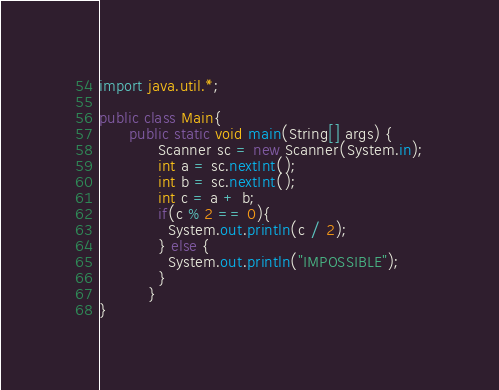<code> <loc_0><loc_0><loc_500><loc_500><_Java_>import java.util.*;

public class Main{
      public static void main(String[] args) {
            Scanner sc = new Scanner(System.in);
            int a = sc.nextInt();
            int b = sc.nextInt();
            int c = a + b;
            if(c % 2 == 0){
              System.out.println(c / 2);
            } else {
              System.out.println("IMPOSSIBLE");
            }
          }
}</code> 